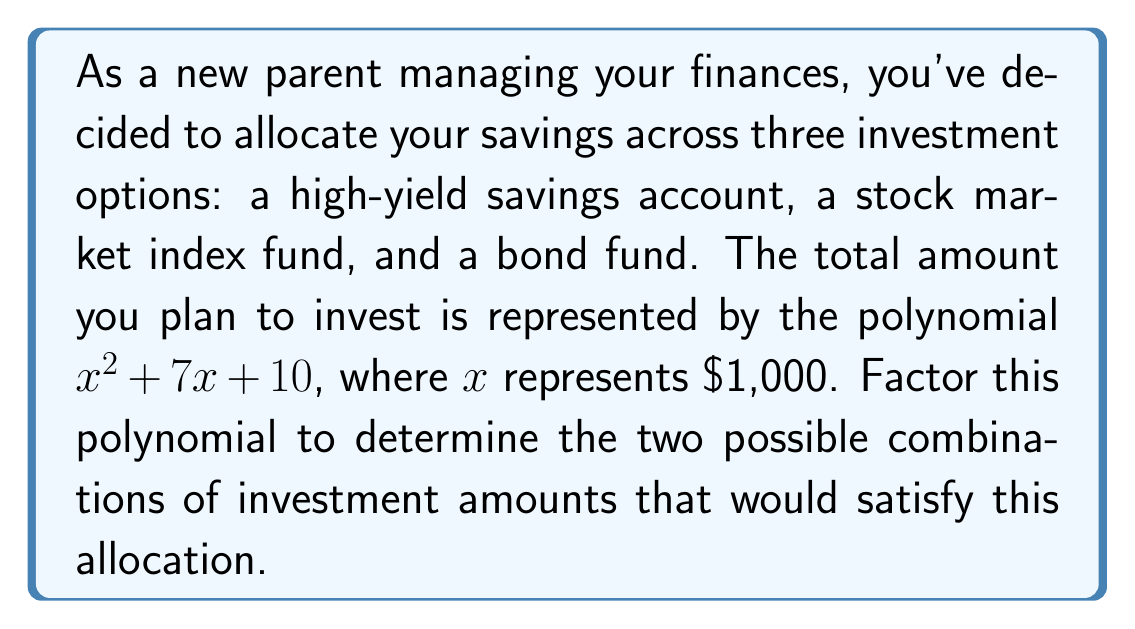Show me your answer to this math problem. To factor the polynomial $x^2 + 7x + 10$, we'll follow these steps:

1) First, we identify that this is a quadratic polynomial in the form $ax^2 + bx + c$, where $a=1$, $b=7$, and $c=10$.

2) We need to find two numbers that multiply to give $ac = 1 \times 10 = 10$ and add up to $b = 7$.

3) The numbers that satisfy this are 5 and 2, as $5 \times 2 = 10$ and $5 + 2 = 7$.

4) We can rewrite the middle term using these numbers:
   $x^2 + 7x + 10 = x^2 + 5x + 2x + 10$

5) Now we can group the terms:
   $(x^2 + 5x) + (2x + 10)$

6) Factor out the common factors from each group:
   $x(x + 5) + 2(x + 5)$

7) We can now factor out the common binomial $(x + 5)$:
   $(x + 5)(x + 2)$

Therefore, the factored form of the polynomial is $(x + 5)(x + 2)$.

In the context of your investments, this means you could allocate your funds in two ways:
1) $5,000 in one option and $2,000 in another
2) $1,000 in the third option (represented by the $x$ term)

Or alternatively:
1) $6,000 in one option ($5,000 + $1,000)
2) $3,000 in another option ($2,000 + $1,000)

Both of these allocations would total $9,000, which is represented by $x^2 + 7x + 10$ when $x = 1$ (remember, $x$ represents $1,000).
Answer: $(x + 5)(x + 2)$ 